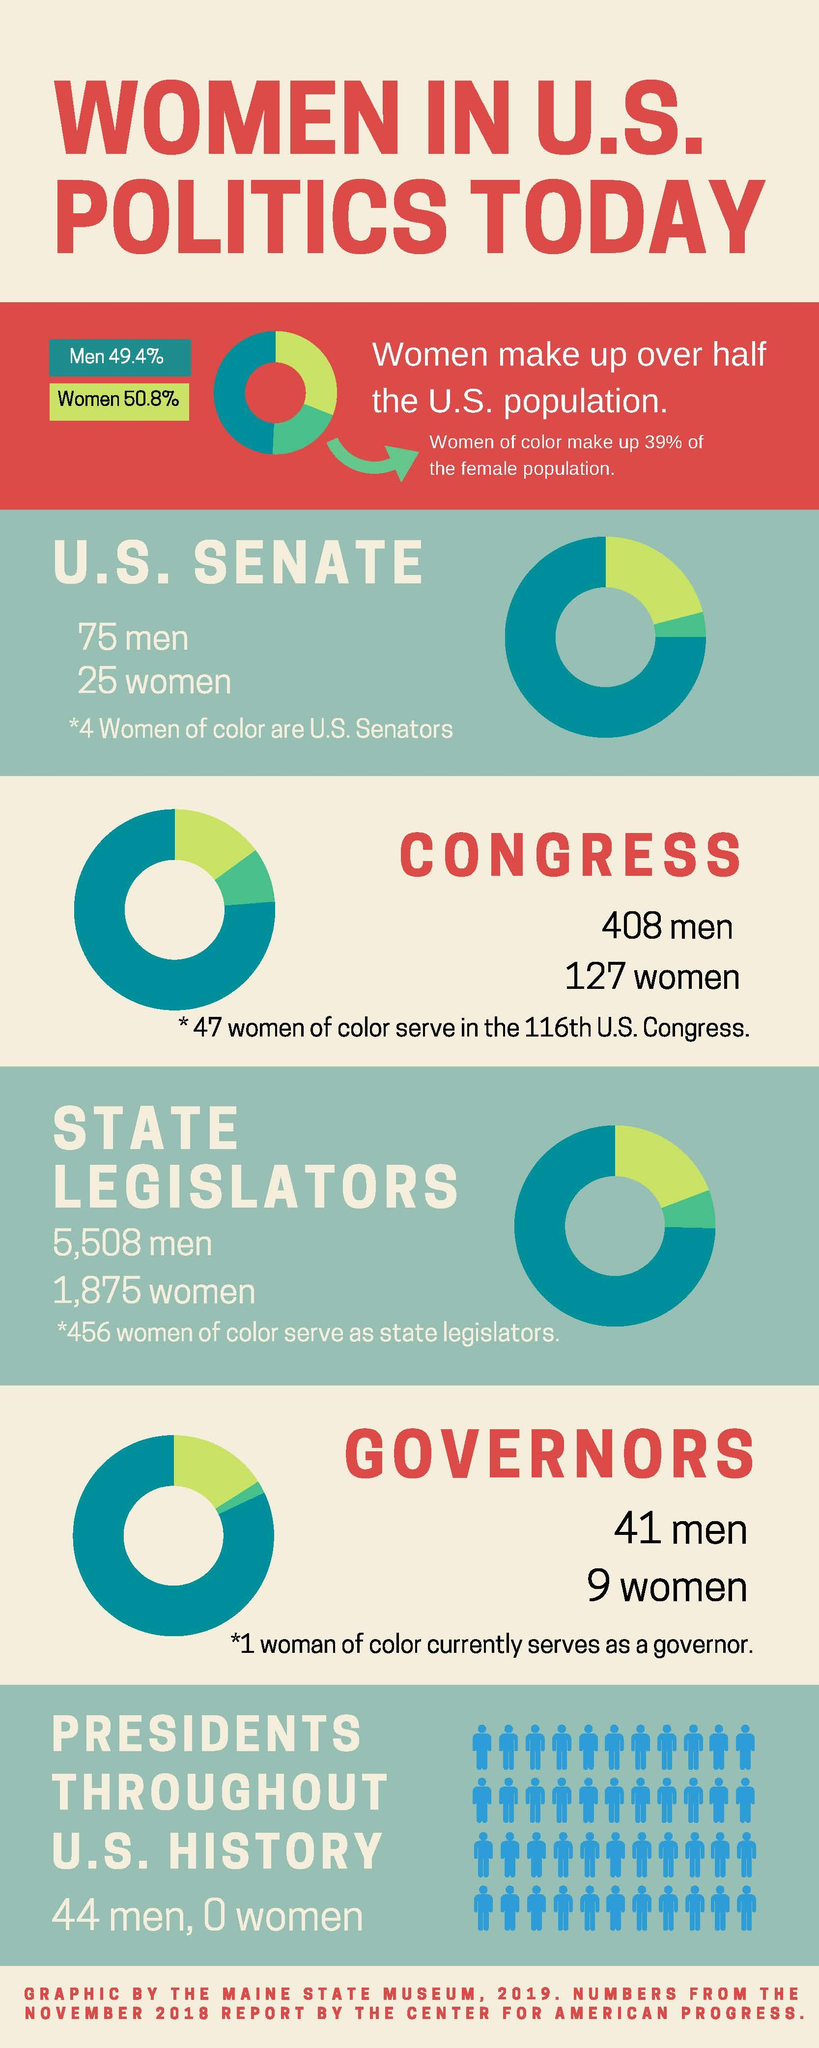Identify some key points in this picture. As of my knowledge cut-off date, there were a total of 7,383 state legislators serving across the United States. In November 2018, a total of 5,508 men had served as state legislators in the United States. As of November 2018, there are currently 9 women serving as US governors. There has never been a woman representative for any position in US politics, including the presidency. In the US Senate, 25% of the members are women. 